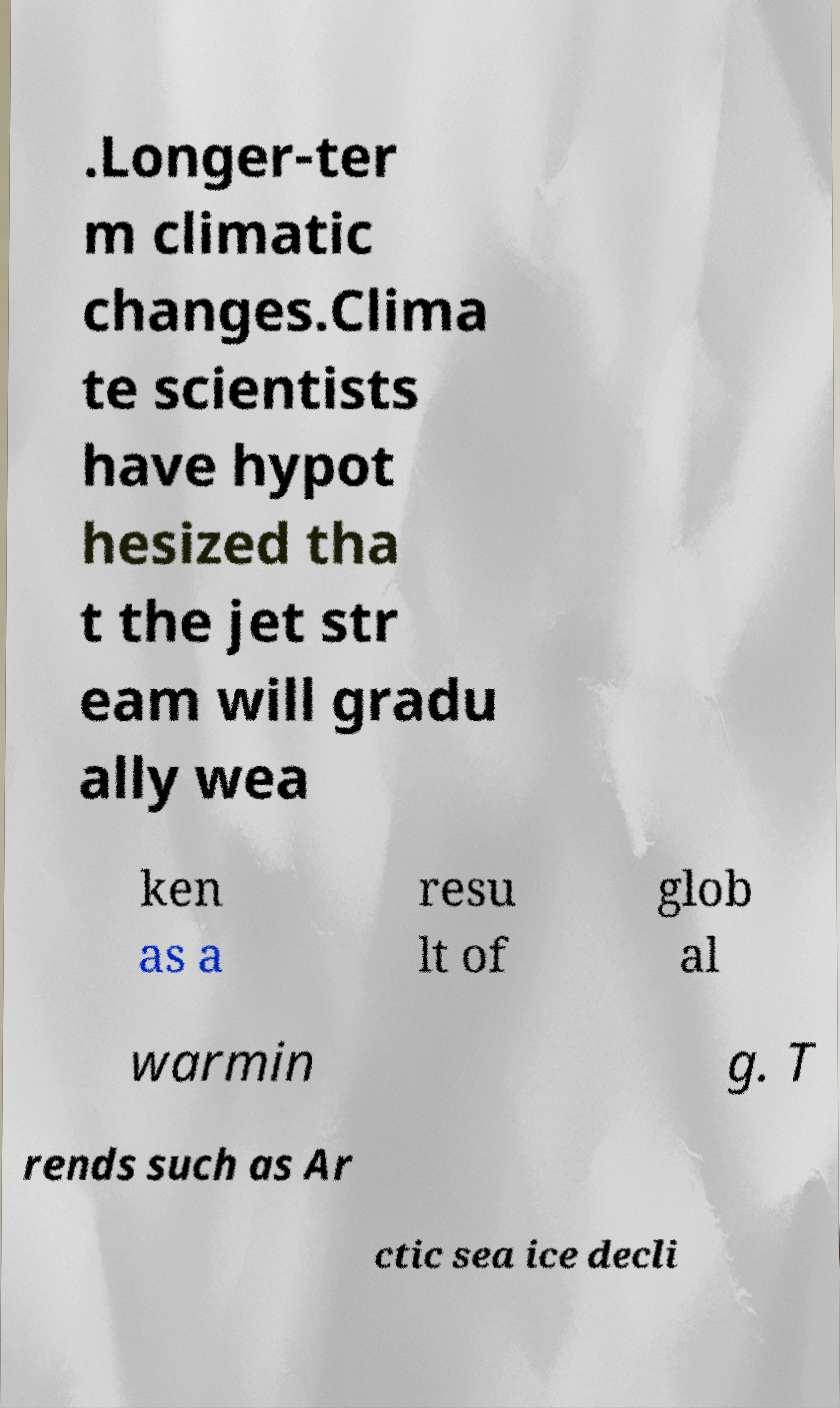What messages or text are displayed in this image? I need them in a readable, typed format. .Longer-ter m climatic changes.Clima te scientists have hypot hesized tha t the jet str eam will gradu ally wea ken as a resu lt of glob al warmin g. T rends such as Ar ctic sea ice decli 